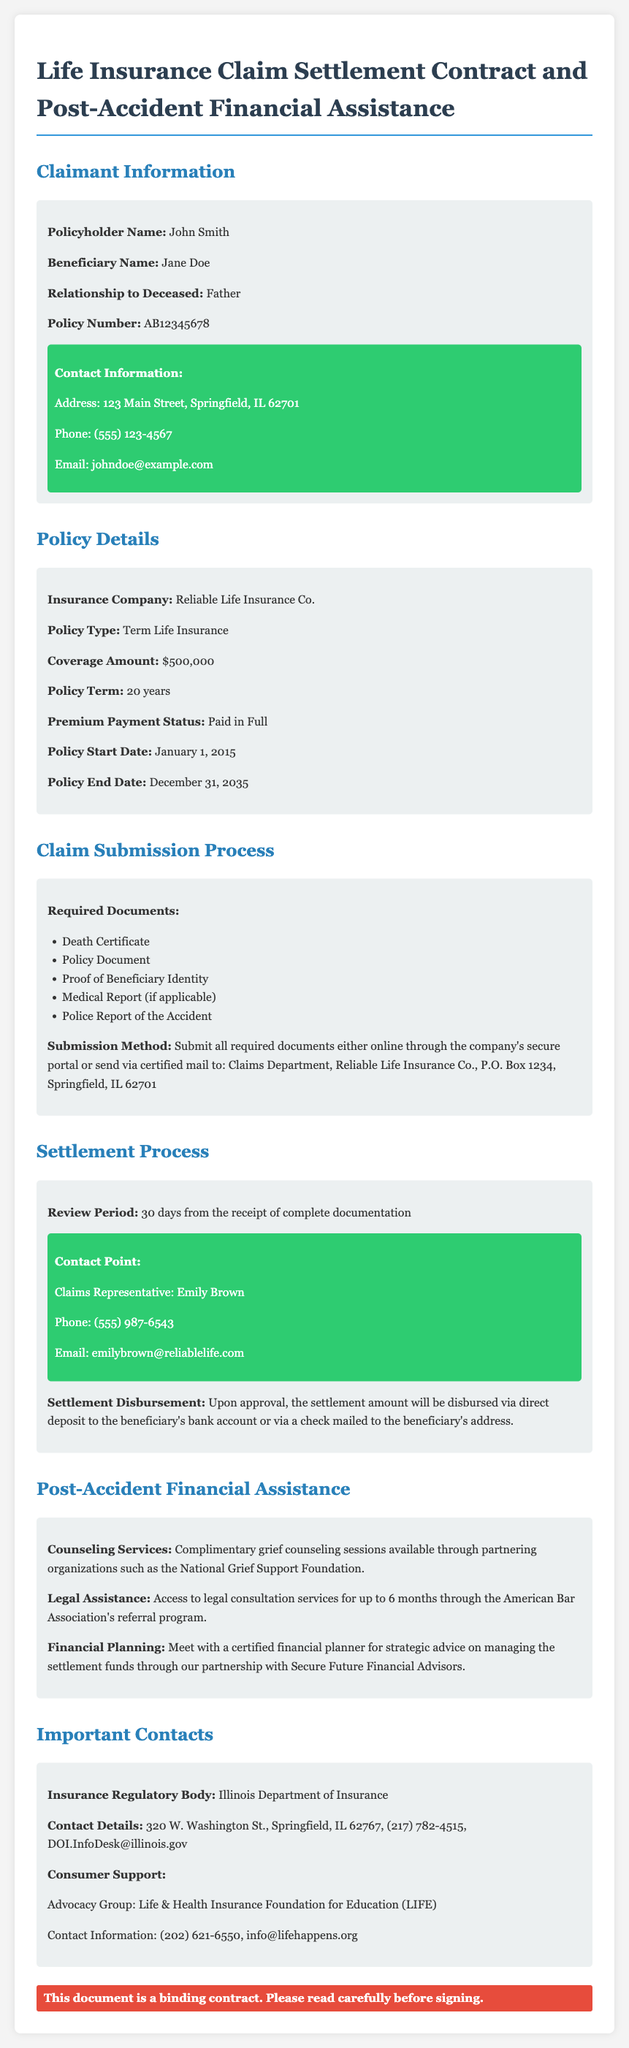What is the policy number? The policy number is given in the Claimant Information section, which states "Policy Number: AB12345678".
Answer: AB12345678 What is the coverage amount? The coverage amount is listed in the Policy Details section, which states "Coverage Amount: $500,000".
Answer: $500,000 Who is the Claims Representative? The Claims Representative's name is found in the Settlement Process section, which states "Claims Representative: Emily Brown".
Answer: Emily Brown How long is the review period? The review period is specified in the Settlement Process section, indicating "Review Period: 30 days from the receipt of complete documentation".
Answer: 30 days What types of assistance are offered post-accident? The Post-Accident Financial Assistance section lists services provided including counseling, legal assistance, and financial planning.
Answer: Counseling, Legal Assistance, Financial Planning What is the premium payment status? The premium payment status is listed in the Policy Details section as "Paid in Full".
Answer: Paid in Full What is the beneficiary relationship to the deceased? The relationship of the beneficiary to the deceased is noted in the Claimant Information section as "Father".
Answer: Father What is the contact email for the Claims Representative? The contact email for the Claims Representative is mentioned in the Settlement Process section, where it states "Email: emilybrown@reliablelife.com".
Answer: emilybrown@reliablelife.com What organization offers grief counseling? The organization providing grief counseling is noted in the Post-Accident Financial Assistance section, specifically "National Grief Support Foundation".
Answer: National Grief Support Foundation 